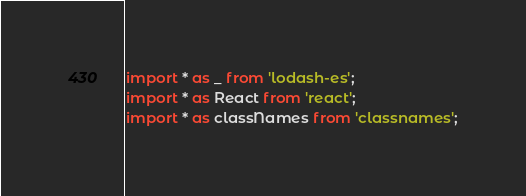<code> <loc_0><loc_0><loc_500><loc_500><_TypeScript_>import * as _ from 'lodash-es';
import * as React from 'react';
import * as classNames from 'classnames';</code> 